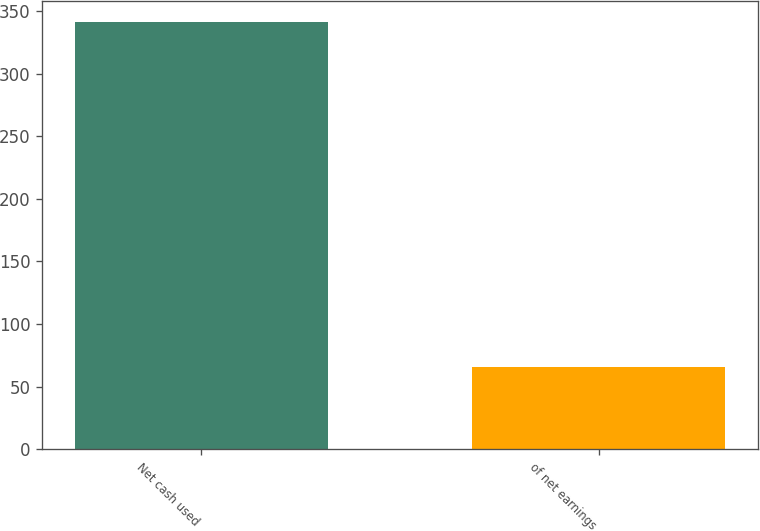<chart> <loc_0><loc_0><loc_500><loc_500><bar_chart><fcel>Net cash used<fcel>of net earnings<nl><fcel>340.9<fcel>66<nl></chart> 